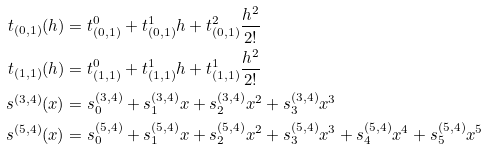<formula> <loc_0><loc_0><loc_500><loc_500>t _ { ( 0 , 1 ) } ( h ) & = t ^ { 0 } _ { ( 0 , 1 ) } + t ^ { 1 } _ { ( 0 , 1 ) } h + t ^ { 2 } _ { ( 0 , 1 ) } \frac { h ^ { 2 } } { 2 ! } \\ t _ { ( 1 , 1 ) } ( h ) & = t ^ { 0 } _ { ( 1 , 1 ) } + t ^ { 1 } _ { ( 1 , 1 ) } h + t ^ { 1 } _ { ( 1 , 1 ) } \frac { h ^ { 2 } } { 2 ! } \\ s ^ { ( 3 , 4 ) } ( x ) & = s ^ { ( 3 , 4 ) } _ { 0 } + s ^ { ( 3 , 4 ) } _ { 1 } x + s ^ { ( 3 , 4 ) } _ { 2 } x ^ { 2 } + s ^ { ( 3 , 4 ) } _ { 3 } x ^ { 3 } \\ s ^ { ( 5 , 4 ) } ( x ) & = s ^ { ( 5 , 4 ) } _ { 0 } + s ^ { ( 5 , 4 ) } _ { 1 } x + s ^ { ( 5 , 4 ) } _ { 2 } x ^ { 2 } + s ^ { ( 5 , 4 ) } _ { 3 } x ^ { 3 } + s ^ { ( 5 , 4 ) } _ { 4 } x ^ { 4 } + s ^ { ( 5 , 4 ) } _ { 5 } x ^ { 5 }</formula> 